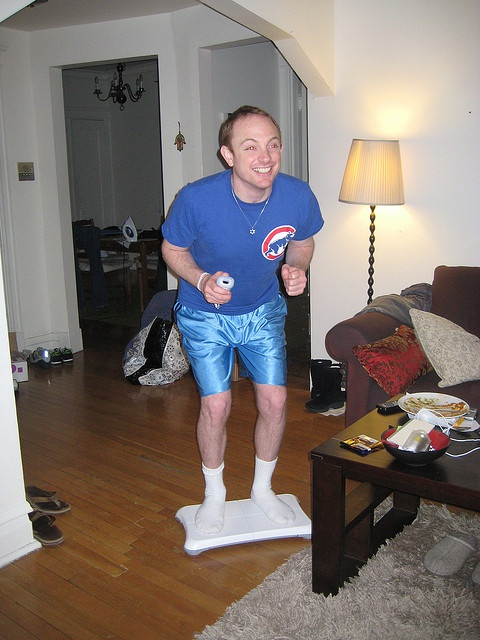Describe the objects in this image and their specific colors. I can see people in darkgray, blue, and lightpink tones, couch in darkgray, maroon, black, and gray tones, remote in darkgray, lightgray, beige, and brown tones, remote in darkgray, black, gray, and olive tones, and remote in darkgray, lavender, and lightblue tones in this image. 